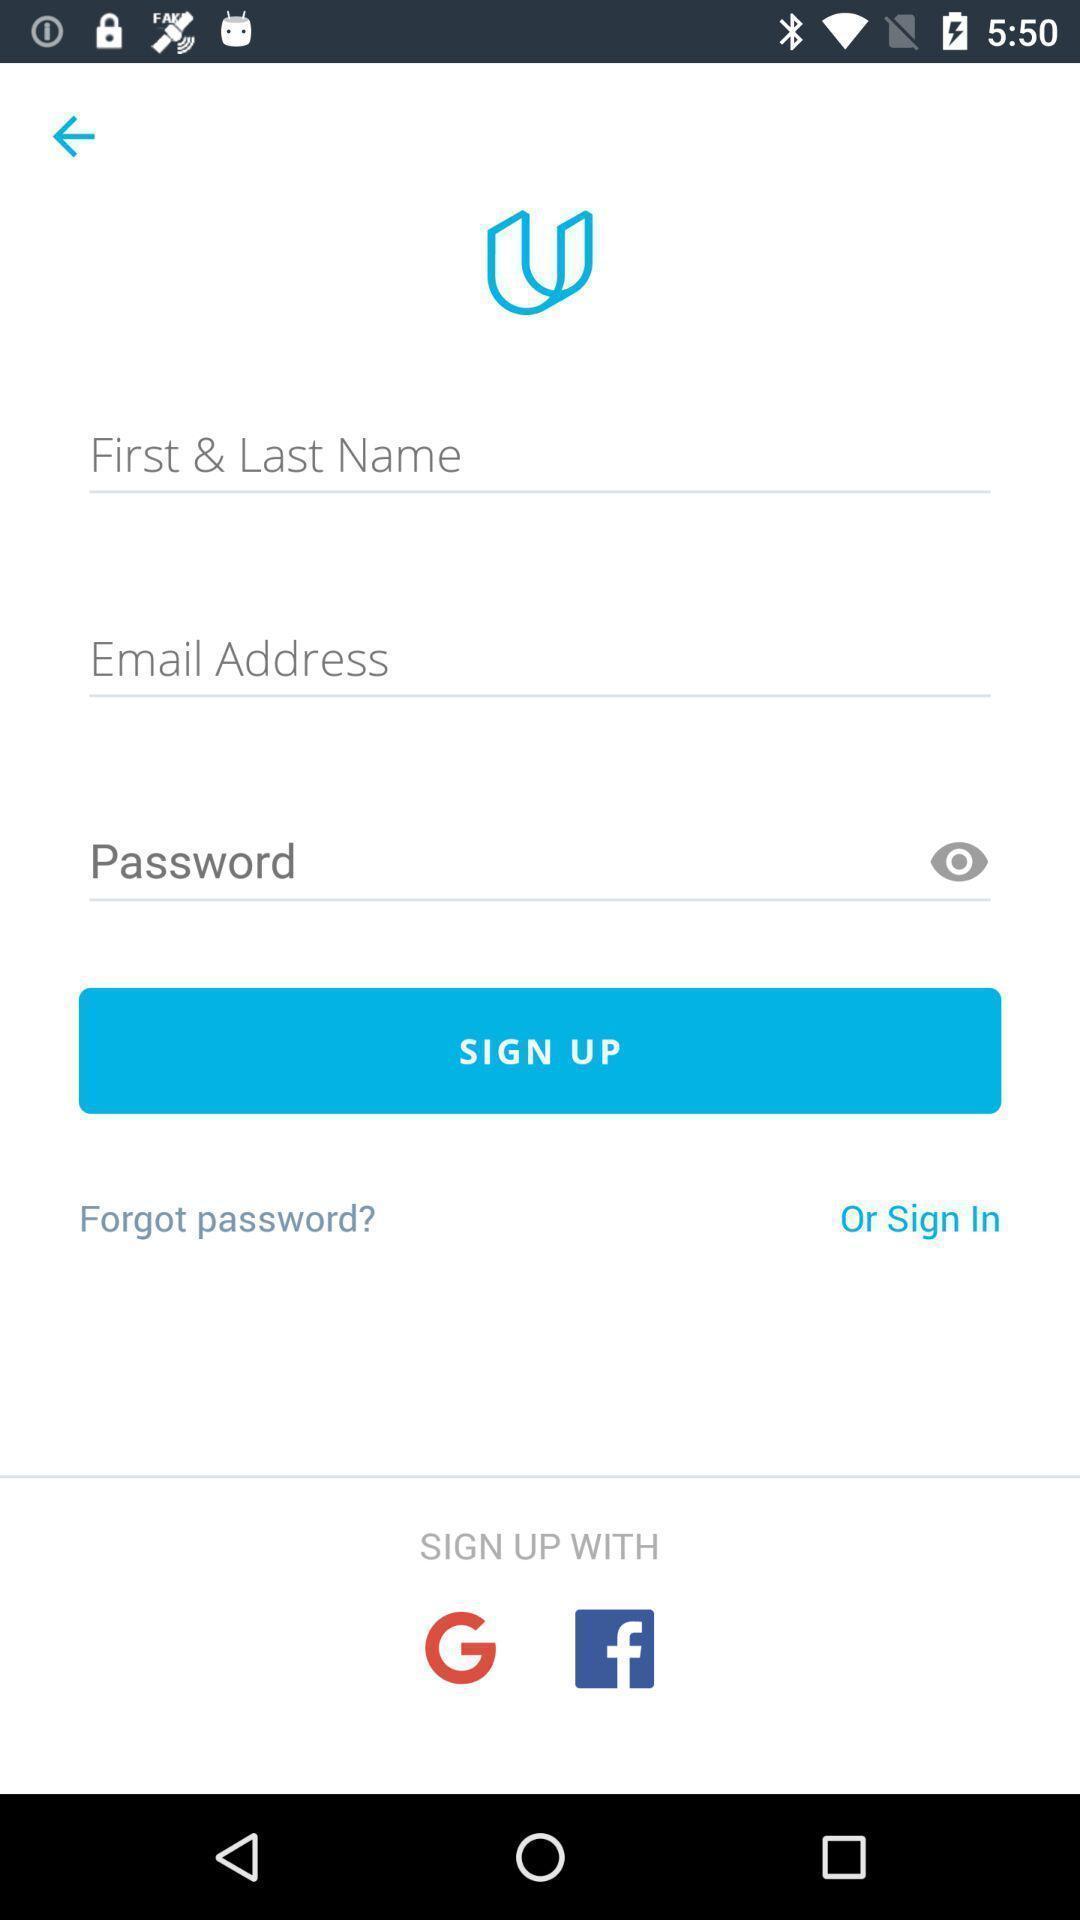Provide a description of this screenshot. Sign up page with different sign-up options. 